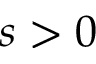Convert formula to latex. <formula><loc_0><loc_0><loc_500><loc_500>s > 0</formula> 